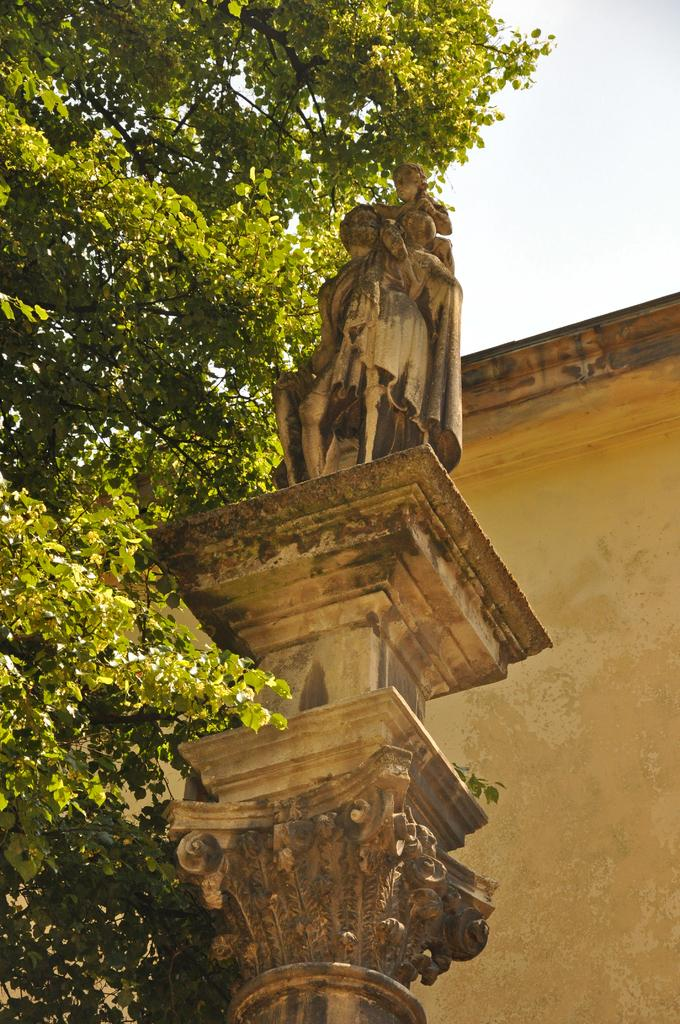What is the main subject in the image? There is a sculpture in the image. What other structures or objects can be seen in the image? There is a building and a tree in the image. How many boys are playing on the wrist in the image? There are no boys or wrists present in the image. 